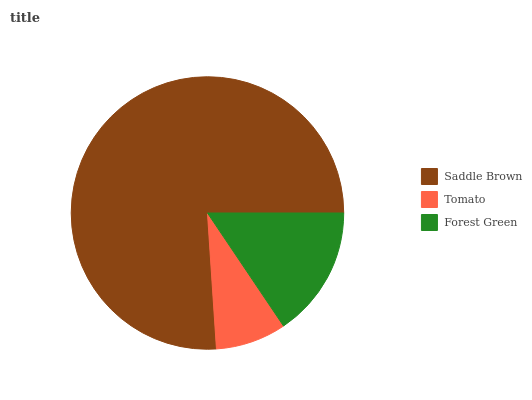Is Tomato the minimum?
Answer yes or no. Yes. Is Saddle Brown the maximum?
Answer yes or no. Yes. Is Forest Green the minimum?
Answer yes or no. No. Is Forest Green the maximum?
Answer yes or no. No. Is Forest Green greater than Tomato?
Answer yes or no. Yes. Is Tomato less than Forest Green?
Answer yes or no. Yes. Is Tomato greater than Forest Green?
Answer yes or no. No. Is Forest Green less than Tomato?
Answer yes or no. No. Is Forest Green the high median?
Answer yes or no. Yes. Is Forest Green the low median?
Answer yes or no. Yes. Is Tomato the high median?
Answer yes or no. No. Is Tomato the low median?
Answer yes or no. No. 